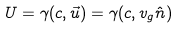<formula> <loc_0><loc_0><loc_500><loc_500>U = \gamma ( c , { \vec { u } } ) = \gamma ( c , v _ { g } { \hat { n } } )</formula> 